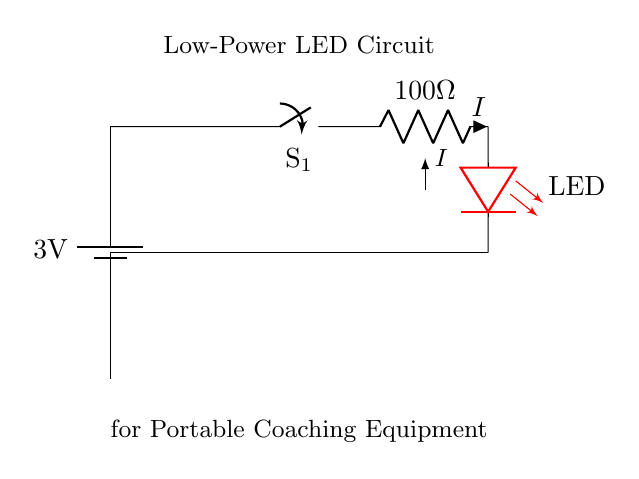What is the voltage of this circuit? The circuit is powered by a battery with a potential difference of 3 volts, indicated on the battery symbol in the diagram.
Answer: 3 volts What is the value of the current limiting resistor? The resistor in the circuit is labeled with a value of 100 ohms, which is indicated next to the resistor symbol.
Answer: 100 ohms Which component acts as the switch in this circuit? The switch is represented by the symbol labeled S1, which can control the flow of current in the circuit.
Answer: S1 What color is the LED in this circuit? The LED is specified to be red, as indicated by the color designation next to the LED symbol in the circuit diagram.
Answer: Red What is the purpose of the current limiting resistor? It is used to limit the amount of current flowing through the LED, protecting it from excess current that could cause damage.
Answer: To limit current If the switch S1 is open, what is the state of the circuit? If the switch is open, there will be no current flow through the circuit, and therefore the LED will not light up.
Answer: No current flow What type of circuit is represented in this diagram? This is a low-power circuit specifically designed for portable applications, as indicated in the title of the diagram.
Answer: Low-power circuit 